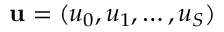Convert formula to latex. <formula><loc_0><loc_0><loc_500><loc_500>{ u } = ( u _ { 0 } , u _ { 1 } , \dots , u _ { S } )</formula> 